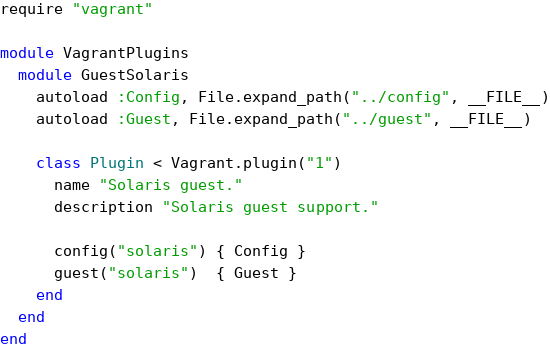<code> <loc_0><loc_0><loc_500><loc_500><_Ruby_>require "vagrant"

module VagrantPlugins
  module GuestSolaris
    autoload :Config, File.expand_path("../config", __FILE__)
    autoload :Guest, File.expand_path("../guest", __FILE__)

    class Plugin < Vagrant.plugin("1")
      name "Solaris guest."
      description "Solaris guest support."

      config("solaris") { Config }
      guest("solaris")  { Guest }
    end
  end
end
</code> 